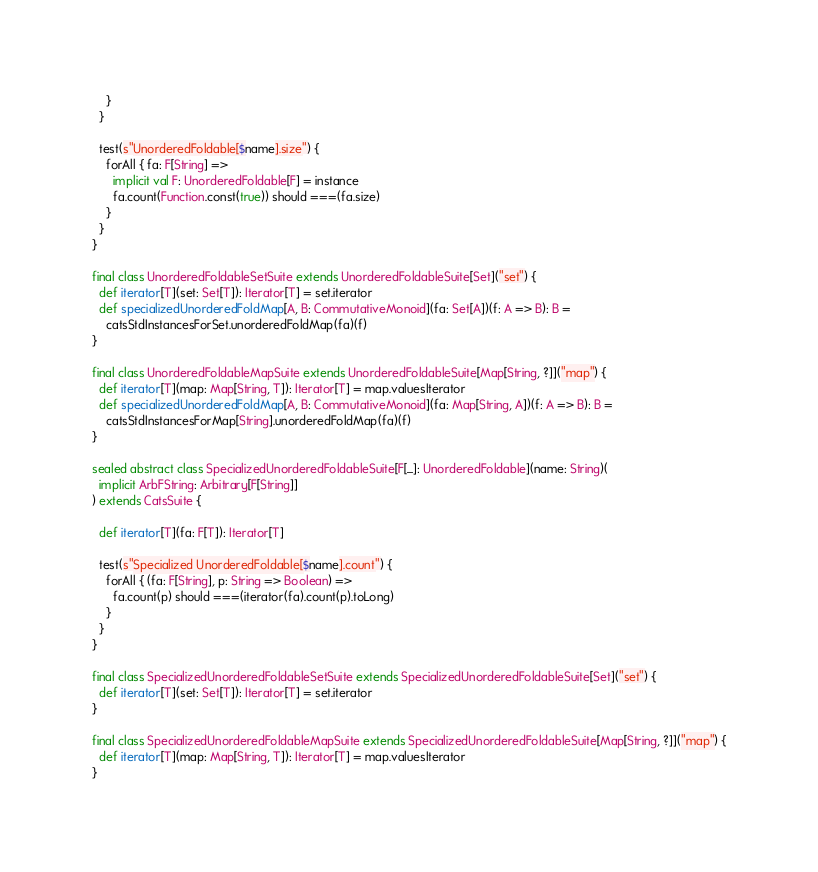<code> <loc_0><loc_0><loc_500><loc_500><_Scala_>    }
  }

  test(s"UnorderedFoldable[$name].size") {
    forAll { fa: F[String] =>
      implicit val F: UnorderedFoldable[F] = instance
      fa.count(Function.const(true)) should ===(fa.size)
    }
  }
}

final class UnorderedFoldableSetSuite extends UnorderedFoldableSuite[Set]("set") {
  def iterator[T](set: Set[T]): Iterator[T] = set.iterator
  def specializedUnorderedFoldMap[A, B: CommutativeMonoid](fa: Set[A])(f: A => B): B =
    catsStdInstancesForSet.unorderedFoldMap(fa)(f)
}

final class UnorderedFoldableMapSuite extends UnorderedFoldableSuite[Map[String, ?]]("map") {
  def iterator[T](map: Map[String, T]): Iterator[T] = map.valuesIterator
  def specializedUnorderedFoldMap[A, B: CommutativeMonoid](fa: Map[String, A])(f: A => B): B =
    catsStdInstancesForMap[String].unorderedFoldMap(fa)(f)
}

sealed abstract class SpecializedUnorderedFoldableSuite[F[_]: UnorderedFoldable](name: String)(
  implicit ArbFString: Arbitrary[F[String]]
) extends CatsSuite {

  def iterator[T](fa: F[T]): Iterator[T]

  test(s"Specialized UnorderedFoldable[$name].count") {
    forAll { (fa: F[String], p: String => Boolean) =>
      fa.count(p) should ===(iterator(fa).count(p).toLong)
    }
  }
}

final class SpecializedUnorderedFoldableSetSuite extends SpecializedUnorderedFoldableSuite[Set]("set") {
  def iterator[T](set: Set[T]): Iterator[T] = set.iterator
}

final class SpecializedUnorderedFoldableMapSuite extends SpecializedUnorderedFoldableSuite[Map[String, ?]]("map") {
  def iterator[T](map: Map[String, T]): Iterator[T] = map.valuesIterator
}
</code> 